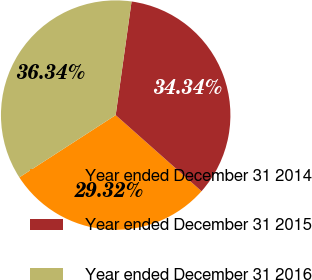Convert chart to OTSL. <chart><loc_0><loc_0><loc_500><loc_500><pie_chart><fcel>Year ended December 31 2014<fcel>Year ended December 31 2015<fcel>Year ended December 31 2016<nl><fcel>29.32%<fcel>34.34%<fcel>36.34%<nl></chart> 